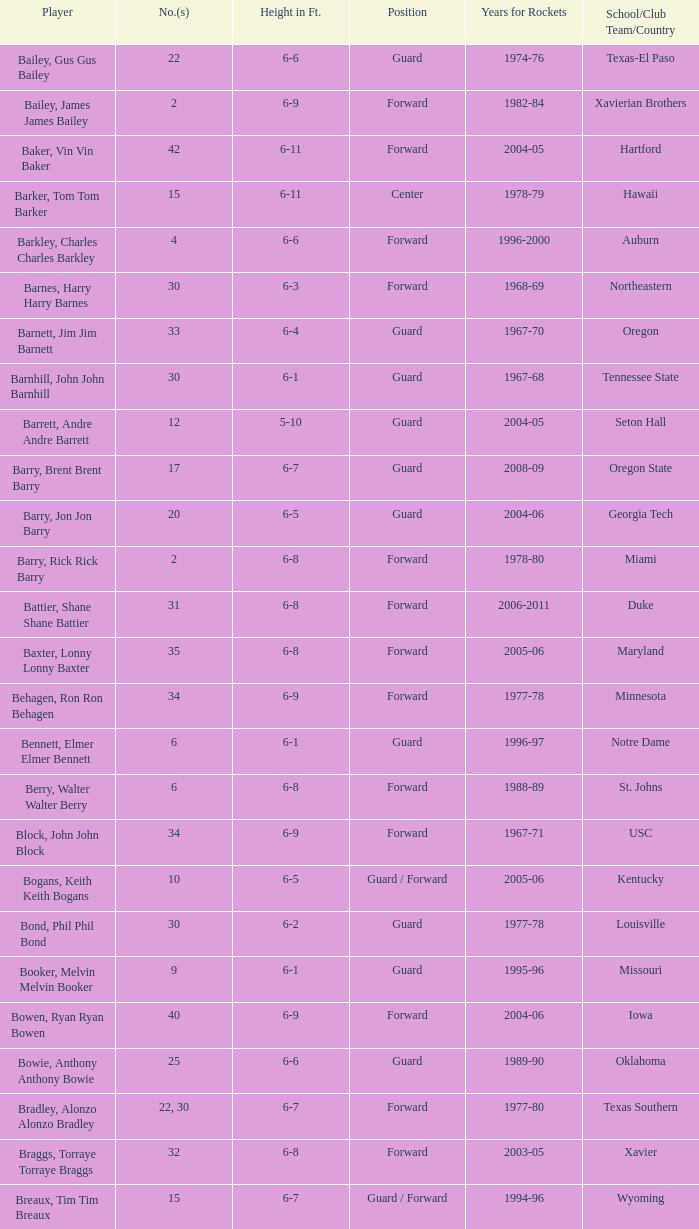During what years was the lasalle player a part of the rockets team? 1982-83. 